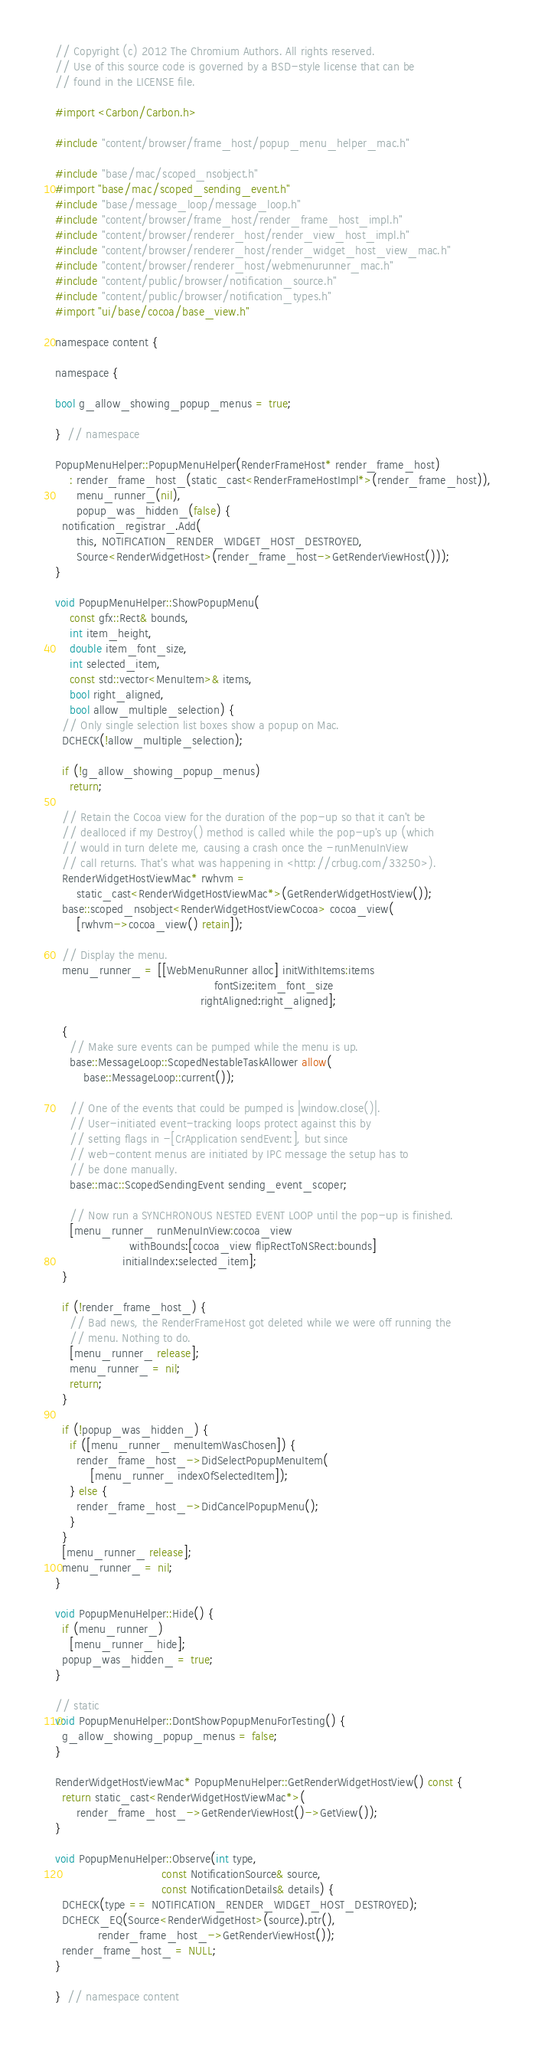<code> <loc_0><loc_0><loc_500><loc_500><_ObjectiveC_>// Copyright (c) 2012 The Chromium Authors. All rights reserved.
// Use of this source code is governed by a BSD-style license that can be
// found in the LICENSE file.

#import <Carbon/Carbon.h>

#include "content/browser/frame_host/popup_menu_helper_mac.h"

#include "base/mac/scoped_nsobject.h"
#import "base/mac/scoped_sending_event.h"
#include "base/message_loop/message_loop.h"
#include "content/browser/frame_host/render_frame_host_impl.h"
#include "content/browser/renderer_host/render_view_host_impl.h"
#include "content/browser/renderer_host/render_widget_host_view_mac.h"
#include "content/browser/renderer_host/webmenurunner_mac.h"
#include "content/public/browser/notification_source.h"
#include "content/public/browser/notification_types.h"
#import "ui/base/cocoa/base_view.h"

namespace content {

namespace {

bool g_allow_showing_popup_menus = true;

}  // namespace

PopupMenuHelper::PopupMenuHelper(RenderFrameHost* render_frame_host)
    : render_frame_host_(static_cast<RenderFrameHostImpl*>(render_frame_host)),
      menu_runner_(nil),
      popup_was_hidden_(false) {
  notification_registrar_.Add(
      this, NOTIFICATION_RENDER_WIDGET_HOST_DESTROYED,
      Source<RenderWidgetHost>(render_frame_host->GetRenderViewHost()));
}

void PopupMenuHelper::ShowPopupMenu(
    const gfx::Rect& bounds,
    int item_height,
    double item_font_size,
    int selected_item,
    const std::vector<MenuItem>& items,
    bool right_aligned,
    bool allow_multiple_selection) {
  // Only single selection list boxes show a popup on Mac.
  DCHECK(!allow_multiple_selection);

  if (!g_allow_showing_popup_menus)
    return;

  // Retain the Cocoa view for the duration of the pop-up so that it can't be
  // dealloced if my Destroy() method is called while the pop-up's up (which
  // would in turn delete me, causing a crash once the -runMenuInView
  // call returns. That's what was happening in <http://crbug.com/33250>).
  RenderWidgetHostViewMac* rwhvm =
      static_cast<RenderWidgetHostViewMac*>(GetRenderWidgetHostView());
  base::scoped_nsobject<RenderWidgetHostViewCocoa> cocoa_view(
      [rwhvm->cocoa_view() retain]);

  // Display the menu.
  menu_runner_ = [[WebMenuRunner alloc] initWithItems:items
                                             fontSize:item_font_size
                                         rightAligned:right_aligned];

  {
    // Make sure events can be pumped while the menu is up.
    base::MessageLoop::ScopedNestableTaskAllower allow(
        base::MessageLoop::current());

    // One of the events that could be pumped is |window.close()|.
    // User-initiated event-tracking loops protect against this by
    // setting flags in -[CrApplication sendEvent:], but since
    // web-content menus are initiated by IPC message the setup has to
    // be done manually.
    base::mac::ScopedSendingEvent sending_event_scoper;

    // Now run a SYNCHRONOUS NESTED EVENT LOOP until the pop-up is finished.
    [menu_runner_ runMenuInView:cocoa_view
                     withBounds:[cocoa_view flipRectToNSRect:bounds]
                   initialIndex:selected_item];
  }

  if (!render_frame_host_) {
    // Bad news, the RenderFrameHost got deleted while we were off running the
    // menu. Nothing to do.
    [menu_runner_ release];
    menu_runner_ = nil;
    return;
  }

  if (!popup_was_hidden_) {
    if ([menu_runner_ menuItemWasChosen]) {
      render_frame_host_->DidSelectPopupMenuItem(
          [menu_runner_ indexOfSelectedItem]);
    } else {
      render_frame_host_->DidCancelPopupMenu();
    }
  }
  [menu_runner_ release];
  menu_runner_ = nil;
}

void PopupMenuHelper::Hide() {
  if (menu_runner_)
    [menu_runner_ hide];
  popup_was_hidden_ = true;
}

// static
void PopupMenuHelper::DontShowPopupMenuForTesting() {
  g_allow_showing_popup_menus = false;
}

RenderWidgetHostViewMac* PopupMenuHelper::GetRenderWidgetHostView() const {
  return static_cast<RenderWidgetHostViewMac*>(
      render_frame_host_->GetRenderViewHost()->GetView());
}

void PopupMenuHelper::Observe(int type,
                              const NotificationSource& source,
                              const NotificationDetails& details) {
  DCHECK(type == NOTIFICATION_RENDER_WIDGET_HOST_DESTROYED);
  DCHECK_EQ(Source<RenderWidgetHost>(source).ptr(),
            render_frame_host_->GetRenderViewHost());
  render_frame_host_ = NULL;
}

}  // namespace content
</code> 